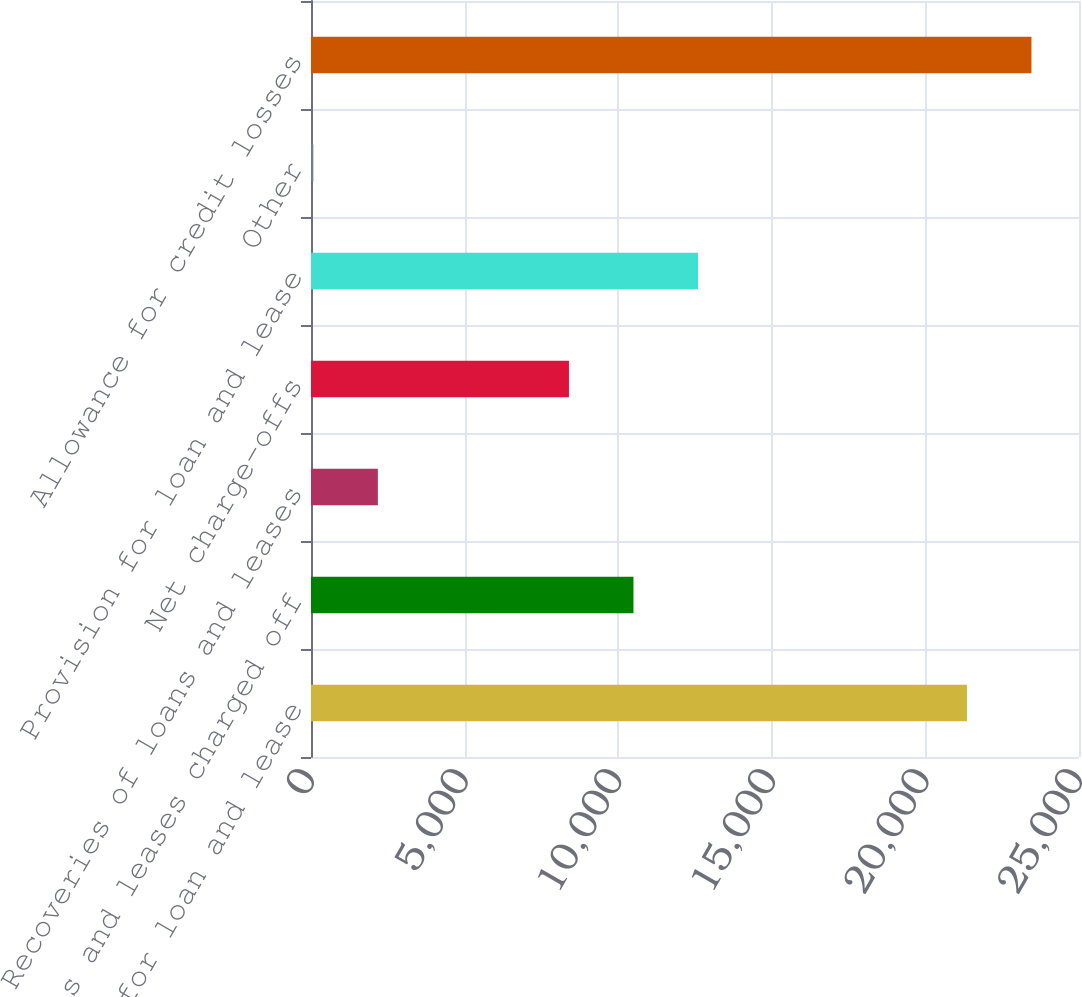<chart> <loc_0><loc_0><loc_500><loc_500><bar_chart><fcel>Allowance for loan and lease<fcel>Loans and leases charged off<fcel>Recoveries of loans and leases<fcel>Net charge-offs<fcel>Provision for loan and lease<fcel>Other<fcel>Allowance for credit losses<nl><fcel>21352.3<fcel>10497.3<fcel>2176.3<fcel>8397<fcel>12597.6<fcel>76<fcel>23452.6<nl></chart> 